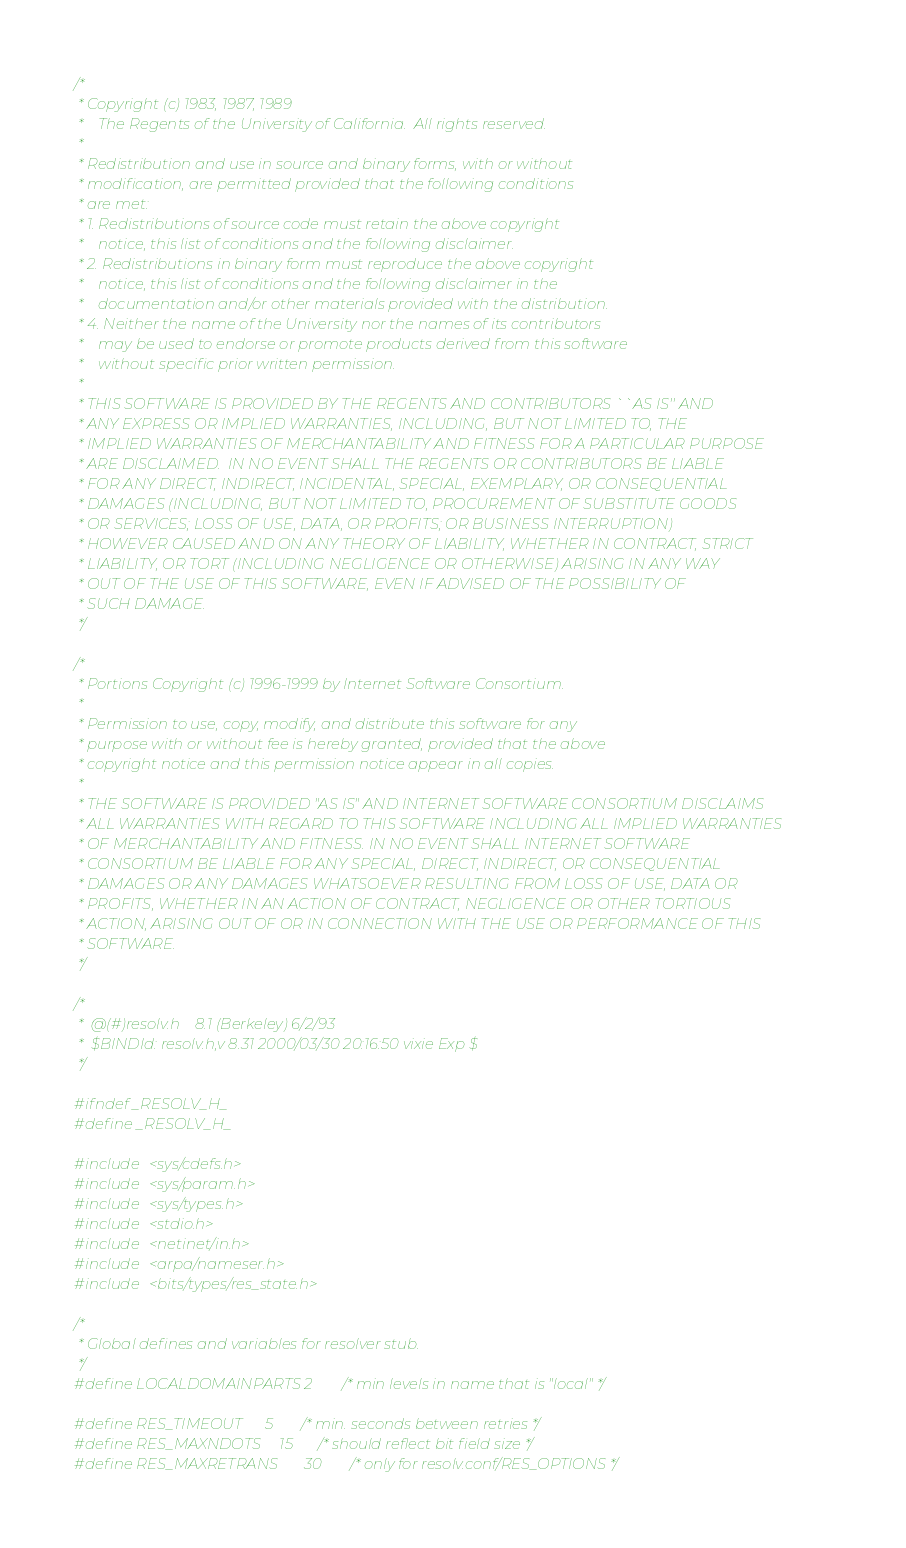Convert code to text. <code><loc_0><loc_0><loc_500><loc_500><_C_>/*
 * Copyright (c) 1983, 1987, 1989
 *    The Regents of the University of California.  All rights reserved.
 *
 * Redistribution and use in source and binary forms, with or without
 * modification, are permitted provided that the following conditions
 * are met:
 * 1. Redistributions of source code must retain the above copyright
 *    notice, this list of conditions and the following disclaimer.
 * 2. Redistributions in binary form must reproduce the above copyright
 *    notice, this list of conditions and the following disclaimer in the
 *    documentation and/or other materials provided with the distribution.
 * 4. Neither the name of the University nor the names of its contributors
 *    may be used to endorse or promote products derived from this software
 *    without specific prior written permission.
 *
 * THIS SOFTWARE IS PROVIDED BY THE REGENTS AND CONTRIBUTORS ``AS IS'' AND
 * ANY EXPRESS OR IMPLIED WARRANTIES, INCLUDING, BUT NOT LIMITED TO, THE
 * IMPLIED WARRANTIES OF MERCHANTABILITY AND FITNESS FOR A PARTICULAR PURPOSE
 * ARE DISCLAIMED.  IN NO EVENT SHALL THE REGENTS OR CONTRIBUTORS BE LIABLE
 * FOR ANY DIRECT, INDIRECT, INCIDENTAL, SPECIAL, EXEMPLARY, OR CONSEQUENTIAL
 * DAMAGES (INCLUDING, BUT NOT LIMITED TO, PROCUREMENT OF SUBSTITUTE GOODS
 * OR SERVICES; LOSS OF USE, DATA, OR PROFITS; OR BUSINESS INTERRUPTION)
 * HOWEVER CAUSED AND ON ANY THEORY OF LIABILITY, WHETHER IN CONTRACT, STRICT
 * LIABILITY, OR TORT (INCLUDING NEGLIGENCE OR OTHERWISE) ARISING IN ANY WAY
 * OUT OF THE USE OF THIS SOFTWARE, EVEN IF ADVISED OF THE POSSIBILITY OF
 * SUCH DAMAGE.
 */

/*
 * Portions Copyright (c) 1996-1999 by Internet Software Consortium.
 *
 * Permission to use, copy, modify, and distribute this software for any
 * purpose with or without fee is hereby granted, provided that the above
 * copyright notice and this permission notice appear in all copies.
 *
 * THE SOFTWARE IS PROVIDED "AS IS" AND INTERNET SOFTWARE CONSORTIUM DISCLAIMS
 * ALL WARRANTIES WITH REGARD TO THIS SOFTWARE INCLUDING ALL IMPLIED WARRANTIES
 * OF MERCHANTABILITY AND FITNESS. IN NO EVENT SHALL INTERNET SOFTWARE
 * CONSORTIUM BE LIABLE FOR ANY SPECIAL, DIRECT, INDIRECT, OR CONSEQUENTIAL
 * DAMAGES OR ANY DAMAGES WHATSOEVER RESULTING FROM LOSS OF USE, DATA OR
 * PROFITS, WHETHER IN AN ACTION OF CONTRACT, NEGLIGENCE OR OTHER TORTIOUS
 * ACTION, ARISING OUT OF OR IN CONNECTION WITH THE USE OR PERFORMANCE OF THIS
 * SOFTWARE.
 */

/*
 *	@(#)resolv.h	8.1 (Berkeley) 6/2/93
 *	$BINDId: resolv.h,v 8.31 2000/03/30 20:16:50 vixie Exp $
 */

#ifndef _RESOLV_H_
#define _RESOLV_H_

#include <sys/cdefs.h>
#include <sys/param.h>
#include <sys/types.h>
#include <stdio.h>
#include <netinet/in.h>
#include <arpa/nameser.h>
#include <bits/types/res_state.h>

/*
 * Global defines and variables for resolver stub.
 */
#define LOCALDOMAINPARTS	2	/* min levels in name that is "local" */

#define RES_TIMEOUT		5	/* min. seconds between retries */
#define RES_MAXNDOTS		15	/* should reflect bit field size */
#define RES_MAXRETRANS		30	/* only for resolv.conf/RES_OPTIONS */</code> 